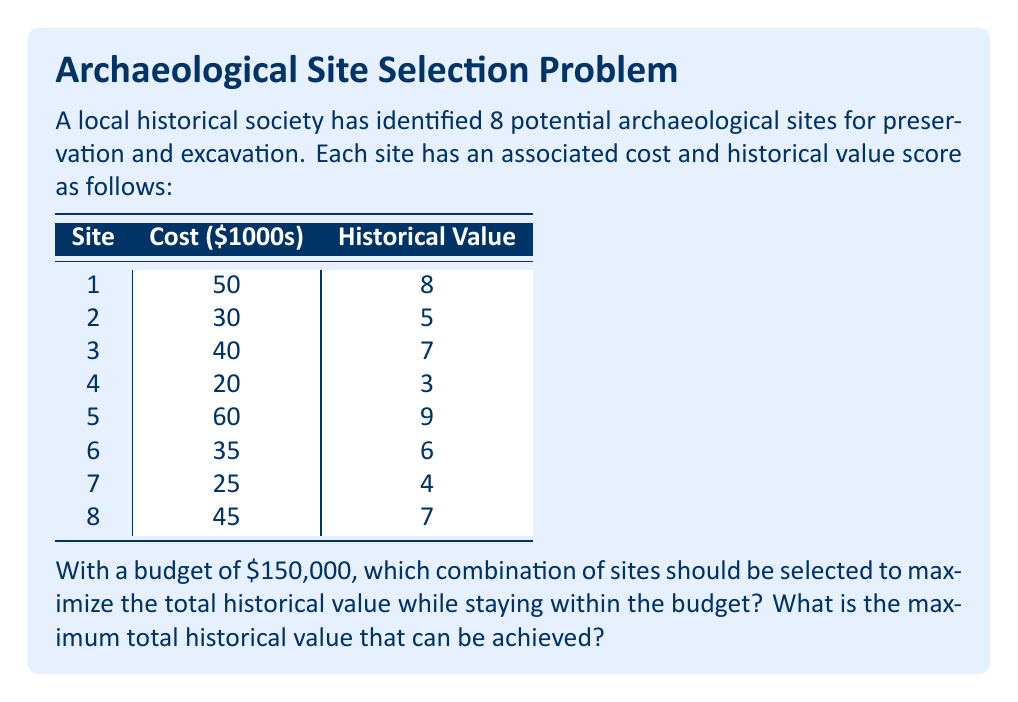Provide a solution to this math problem. This problem is a classic example of the 0-1 Knapsack Problem, which can be solved using dynamic programming. Let's approach this step-by-step:

1) First, we'll create a table where rows represent the sites (0 to 8) and columns represent the budget in thousands of dollars (0 to 150).

2) We'll fill this table using the following recurrence relation:

   Let $V[i][j]$ be the maximum value achievable with the first $i$ items and a budget of $j$ thousand dollars.

   $$V[i][j] = \max(V[i-1][j], V[i-1][j-c_i] + v_i)$$

   where $c_i$ is the cost of the $i$-th item and $v_i$ is its value.

3) We'll fill the table row by row. For each cell, we'll consider whether to include the current site or not.

4) After filling the table, the value in $V[8][150]$ will give us the maximum historical value achievable.

5) To determine which sites were selected, we'll backtrack from $V[8][150]$.

Here's a partial view of the filled table (showing only every 10th column for brevity):

```
    0   10   20  ...  140  150
0   0    0    0  ...    0    0
1   0    0    0  ...    8    8
2   0    0    5  ...   13   13
3   0    0    5  ...   15   15
4   0    3    5  ...   15   15
5   0    3    5  ...   17   17
6   0    3    6  ...   21   23
7   0    4    7  ...   21   23
8   0    4    7  ...   25   25
```

Backtracking from $V[8][150] = 25$, we can determine that sites 1, 3, 5, and 8 were selected.
Answer: The optimal combination of sites to select is 1, 3, 5, and 8. The maximum total historical value that can be achieved is 25, with a total cost of $145,000, which is within the $150,000 budget. 